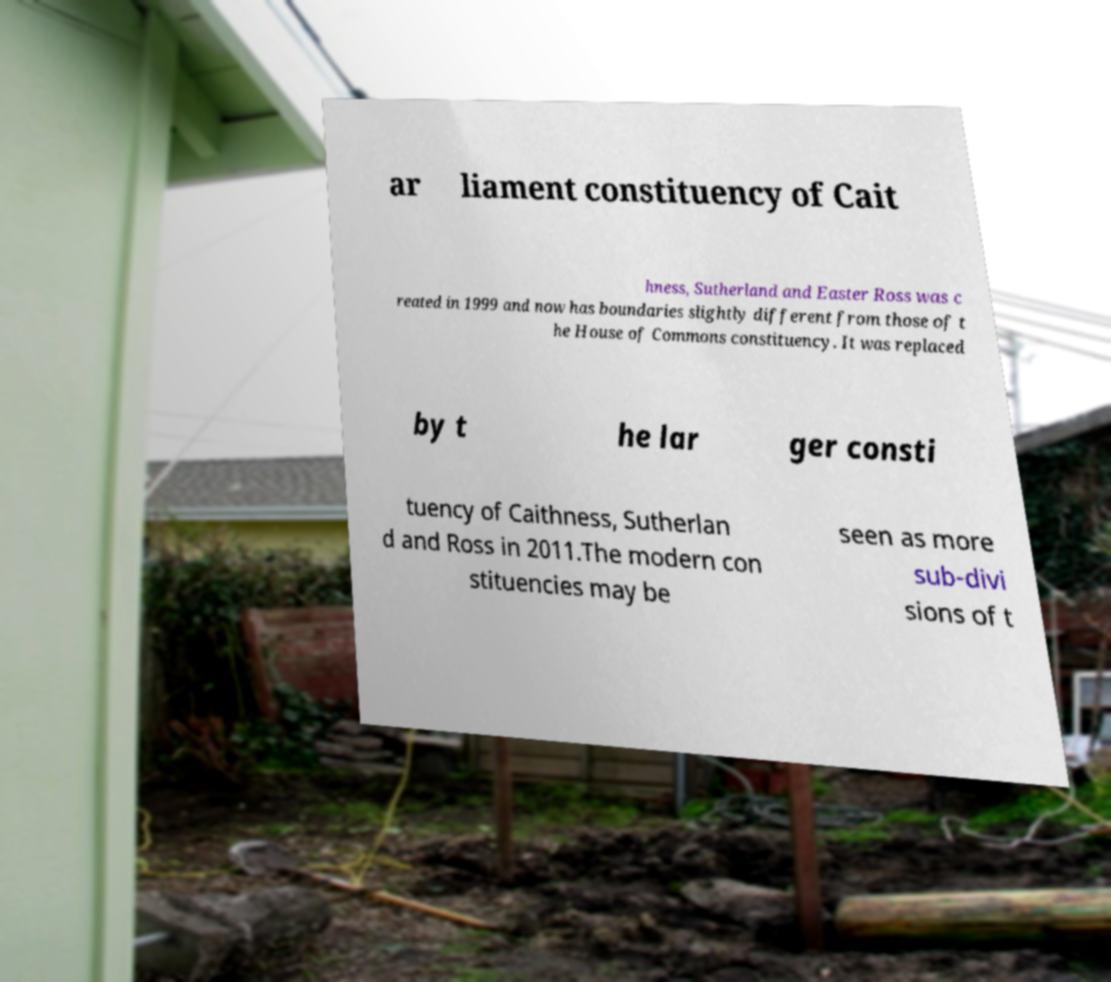What messages or text are displayed in this image? I need them in a readable, typed format. ar liament constituency of Cait hness, Sutherland and Easter Ross was c reated in 1999 and now has boundaries slightly different from those of t he House of Commons constituency. It was replaced by t he lar ger consti tuency of Caithness, Sutherlan d and Ross in 2011.The modern con stituencies may be seen as more sub-divi sions of t 